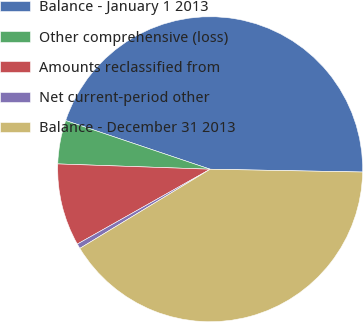Convert chart. <chart><loc_0><loc_0><loc_500><loc_500><pie_chart><fcel>Balance - January 1 2013<fcel>Other comprehensive (loss)<fcel>Amounts reclassified from<fcel>Net current-period other<fcel>Balance - December 31 2013<nl><fcel>45.12%<fcel>4.62%<fcel>8.72%<fcel>0.52%<fcel>41.02%<nl></chart> 